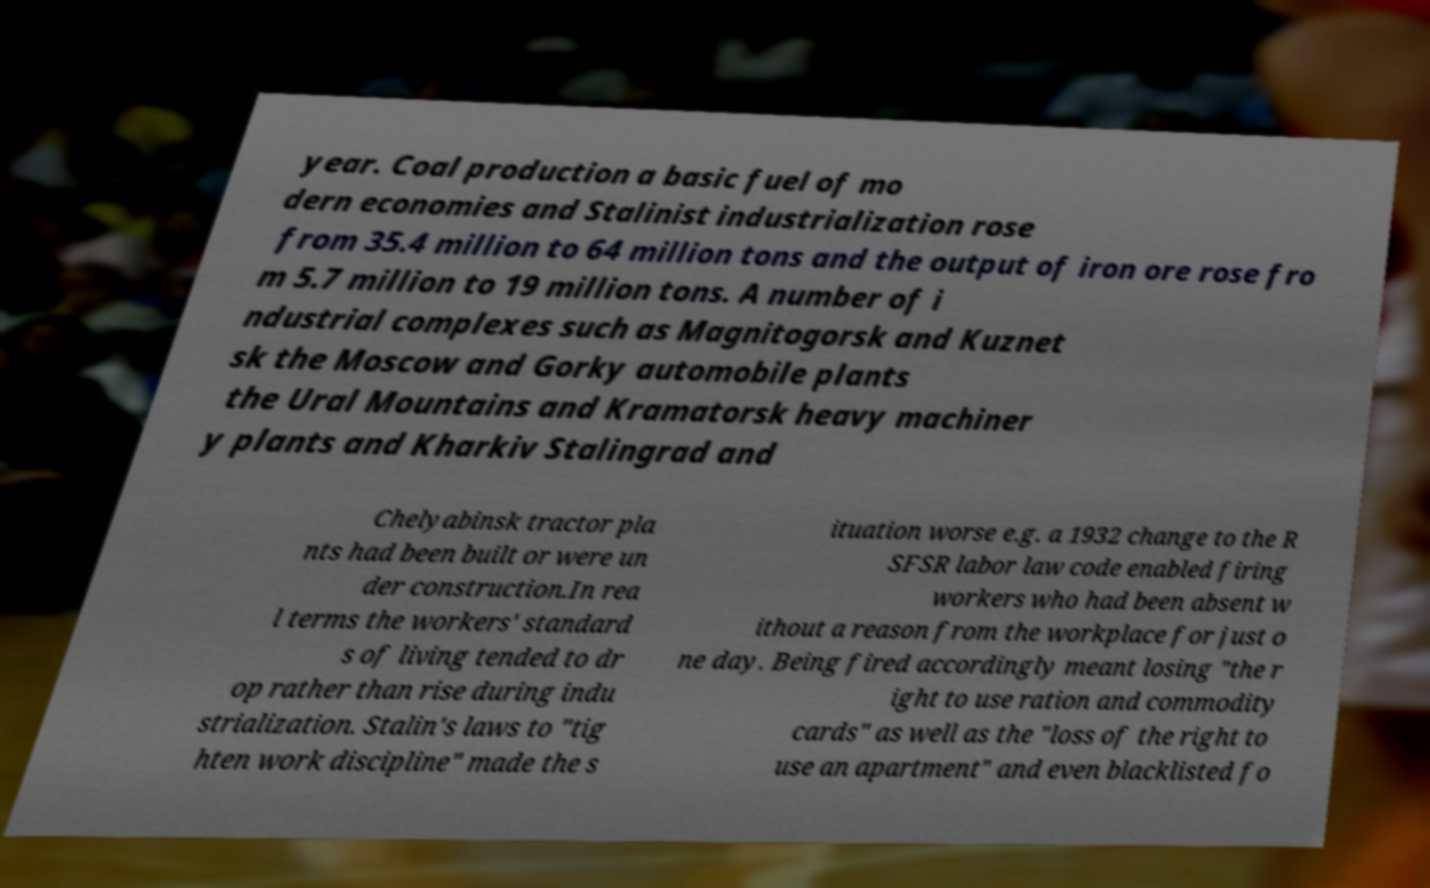For documentation purposes, I need the text within this image transcribed. Could you provide that? year. Coal production a basic fuel of mo dern economies and Stalinist industrialization rose from 35.4 million to 64 million tons and the output of iron ore rose fro m 5.7 million to 19 million tons. A number of i ndustrial complexes such as Magnitogorsk and Kuznet sk the Moscow and Gorky automobile plants the Ural Mountains and Kramatorsk heavy machiner y plants and Kharkiv Stalingrad and Chelyabinsk tractor pla nts had been built or were un der construction.In rea l terms the workers' standard s of living tended to dr op rather than rise during indu strialization. Stalin's laws to "tig hten work discipline" made the s ituation worse e.g. a 1932 change to the R SFSR labor law code enabled firing workers who had been absent w ithout a reason from the workplace for just o ne day. Being fired accordingly meant losing "the r ight to use ration and commodity cards" as well as the "loss of the right to use an apartment″ and even blacklisted fo 